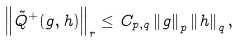Convert formula to latex. <formula><loc_0><loc_0><loc_500><loc_500>\left \| \tilde { Q } ^ { + } ( g , h ) \right \| _ { r } \leq C _ { p , q } \left \| g \right \| _ { p } \left \| h \right \| _ { q } ,</formula> 